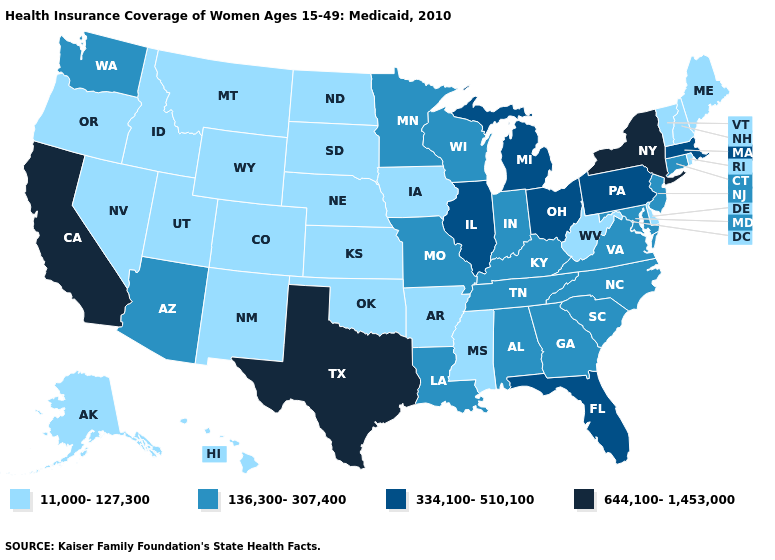How many symbols are there in the legend?
Keep it brief. 4. Does Texas have the highest value in the USA?
Answer briefly. Yes. Which states have the lowest value in the West?
Give a very brief answer. Alaska, Colorado, Hawaii, Idaho, Montana, Nevada, New Mexico, Oregon, Utah, Wyoming. What is the value of California?
Write a very short answer. 644,100-1,453,000. Among the states that border California , which have the lowest value?
Concise answer only. Nevada, Oregon. Which states hav the highest value in the Northeast?
Quick response, please. New York. How many symbols are there in the legend?
Answer briefly. 4. What is the lowest value in the USA?
Keep it brief. 11,000-127,300. Does New York have the lowest value in the Northeast?
Quick response, please. No. Which states have the lowest value in the South?
Keep it brief. Arkansas, Delaware, Mississippi, Oklahoma, West Virginia. What is the lowest value in the West?
Short answer required. 11,000-127,300. Name the states that have a value in the range 644,100-1,453,000?
Concise answer only. California, New York, Texas. Name the states that have a value in the range 644,100-1,453,000?
Quick response, please. California, New York, Texas. What is the value of South Carolina?
Short answer required. 136,300-307,400. What is the value of Idaho?
Write a very short answer. 11,000-127,300. 